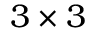<formula> <loc_0><loc_0><loc_500><loc_500>3 \times 3</formula> 